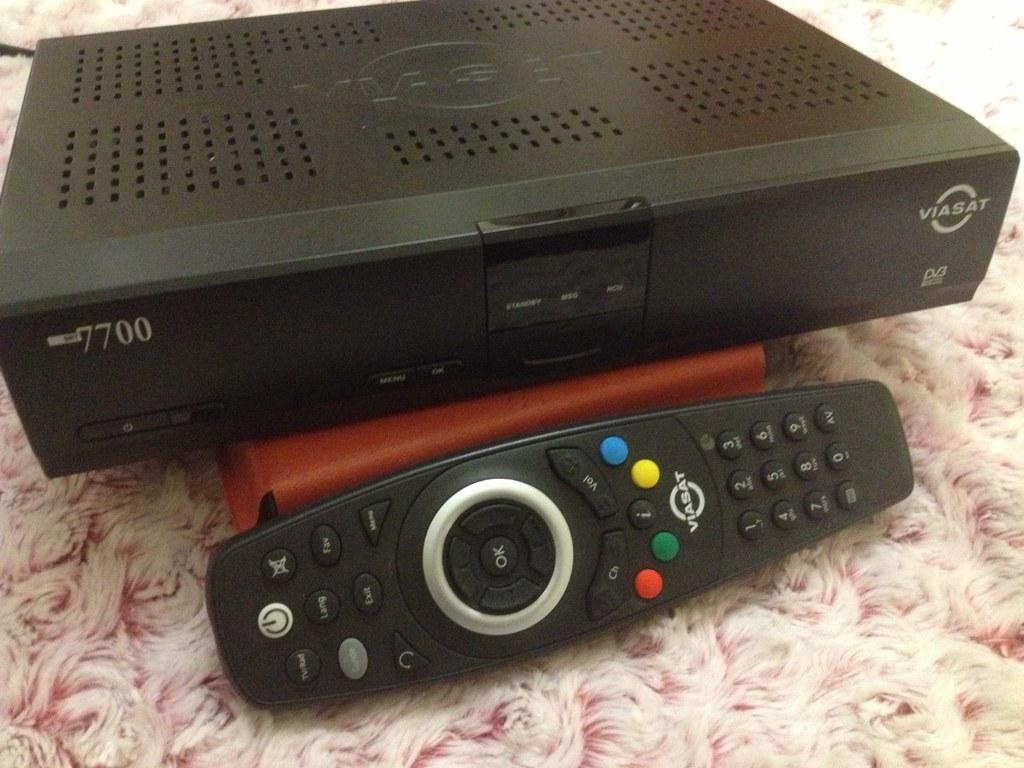<image>
Write a terse but informative summary of the picture. The elecrtical device shown is made by Viasat. 